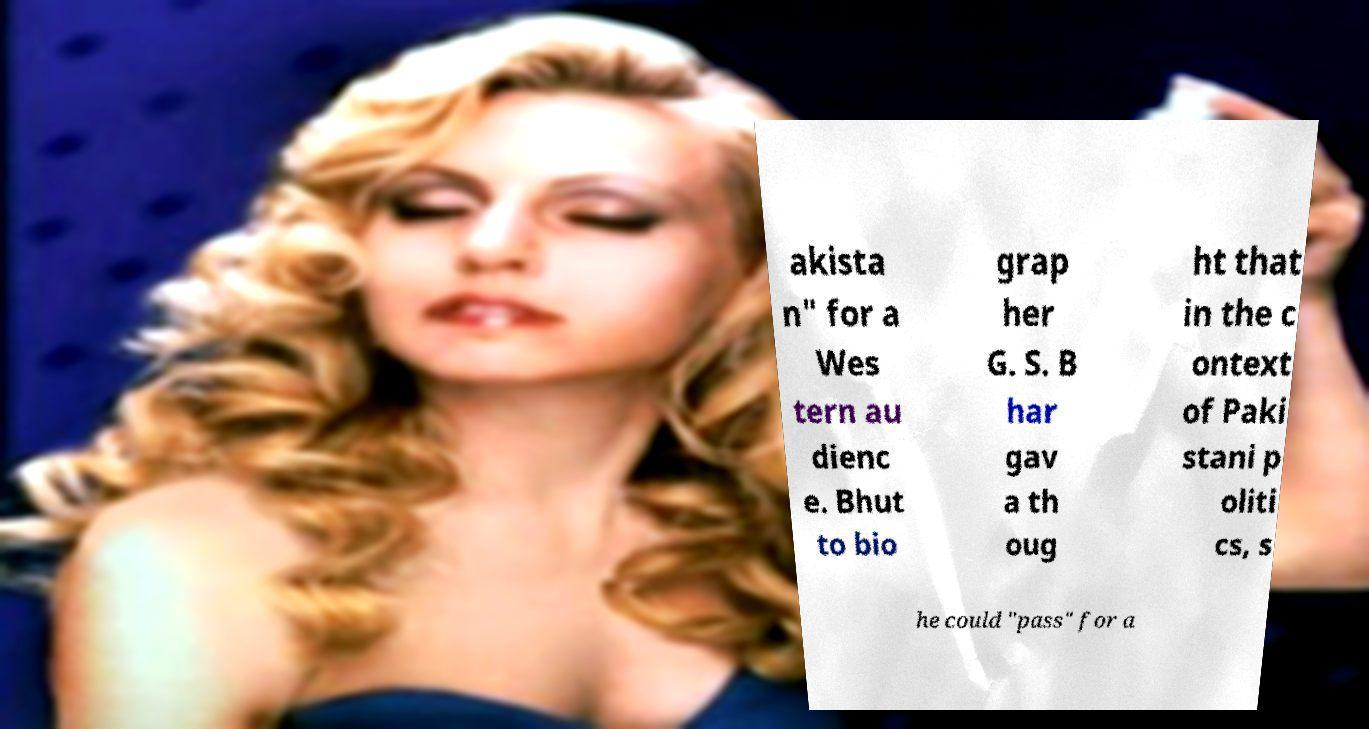Could you extract and type out the text from this image? akista n" for a Wes tern au dienc e. Bhut to bio grap her G. S. B har gav a th oug ht that in the c ontext of Paki stani p oliti cs, s he could "pass" for a 